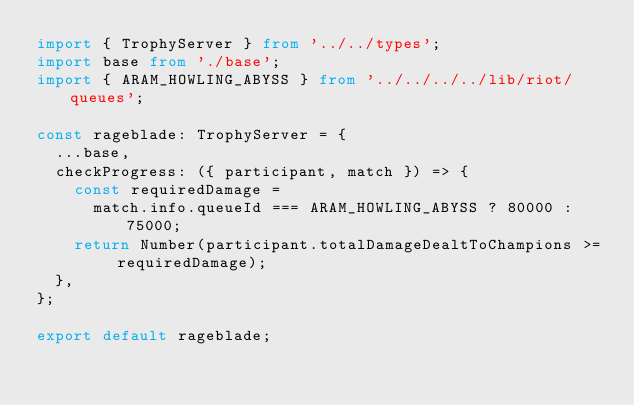Convert code to text. <code><loc_0><loc_0><loc_500><loc_500><_TypeScript_>import { TrophyServer } from '../../types';
import base from './base';
import { ARAM_HOWLING_ABYSS } from '../../../../lib/riot/queues';

const rageblade: TrophyServer = {
  ...base,
  checkProgress: ({ participant, match }) => {
    const requiredDamage =
      match.info.queueId === ARAM_HOWLING_ABYSS ? 80000 : 75000;
    return Number(participant.totalDamageDealtToChampions >= requiredDamage);
  },
};

export default rageblade;
</code> 